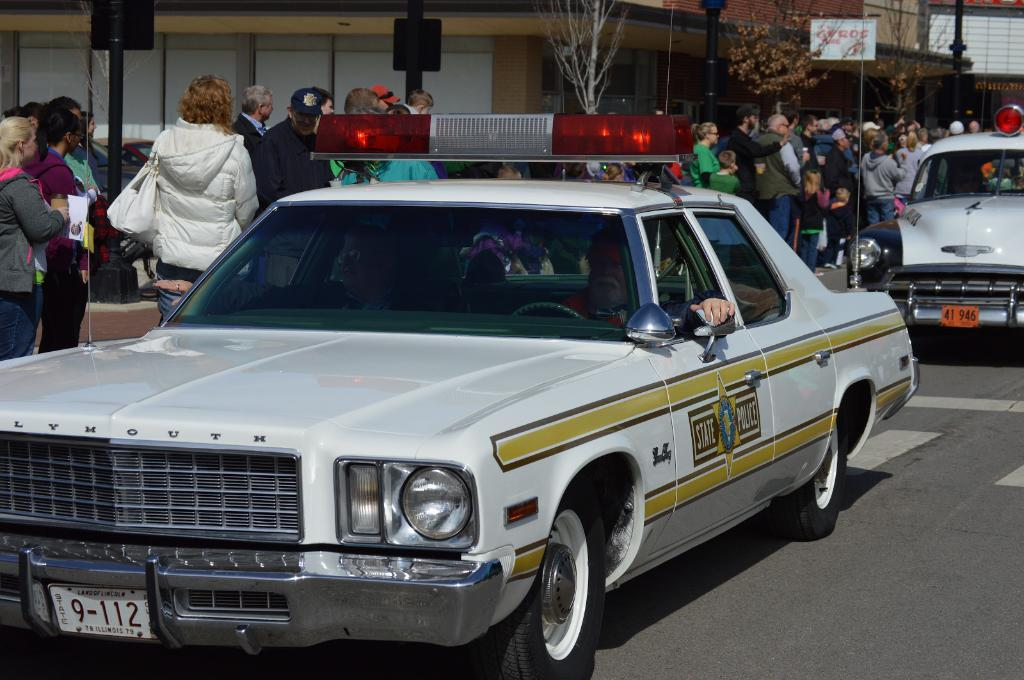How many people are in the group that is visible in the image? There is a group of people in the image, but the exact number is not specified. What are some people in the group holding? Some people in the group are holding bags. What can be seen on the road in the image? There are vehicles on the road in the image. What type of structures are visible in the image? There are poles and at least one building visible in the image. What type of vegetation is present in the image? There are trees in the image. What type of cabbage is being used as a finger puppet in the image? There is no cabbage or finger puppet present in the image. 